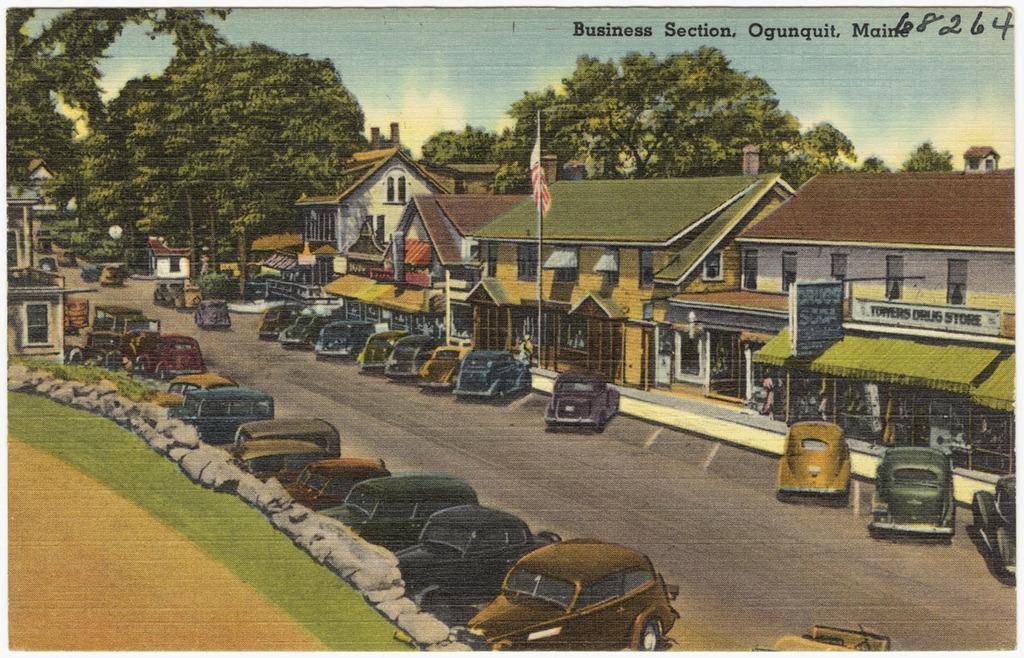Could you give a brief overview of what you see in this image? This image consists of a poster in which there are many cars parked on the road. In the background, there are trees. At the top, there is sky. In the front, we can see many houses. On the left, there is green grass on the ground along with the rocks. 